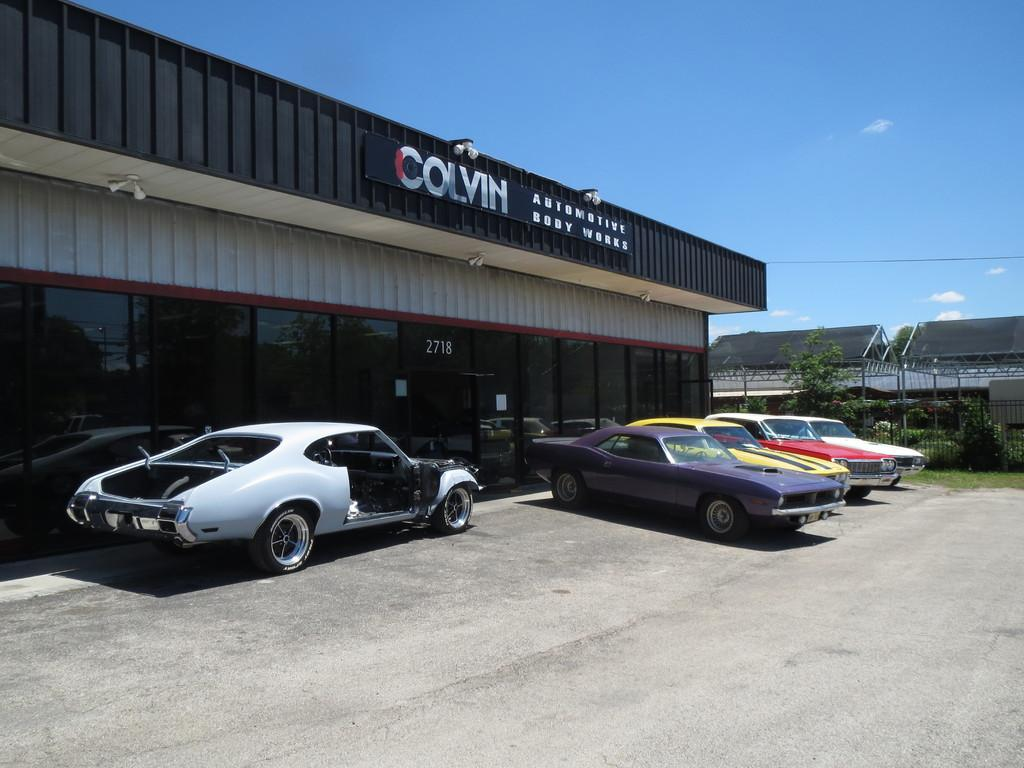Where was the image taken? The image was clicked outside. What can be seen in the middle of the image? There is a door and cars in the middle of the image. What type of vegetation is on the right side of the image? There are plants and bushes on the right side of the image. What is visible at the top of the image? The sky is visible at the top of the image. What type of orange tree can be seen in the image? There is no orange tree present in the image. What is the reward for finding the zinc in the image? There is no zinc or reward mentioned in the image. 